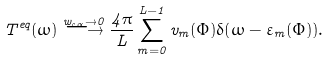<formula> <loc_0><loc_0><loc_500><loc_500>T ^ { e q } ( \omega ) \stackrel { w _ { c \alpha } \rightarrow 0 } { \longrightarrow } \frac { 4 \pi } { L } \sum _ { m = 0 } ^ { L - 1 } v _ { m } ( \Phi ) \delta ( \omega - \varepsilon _ { m } ( \Phi ) ) .</formula> 